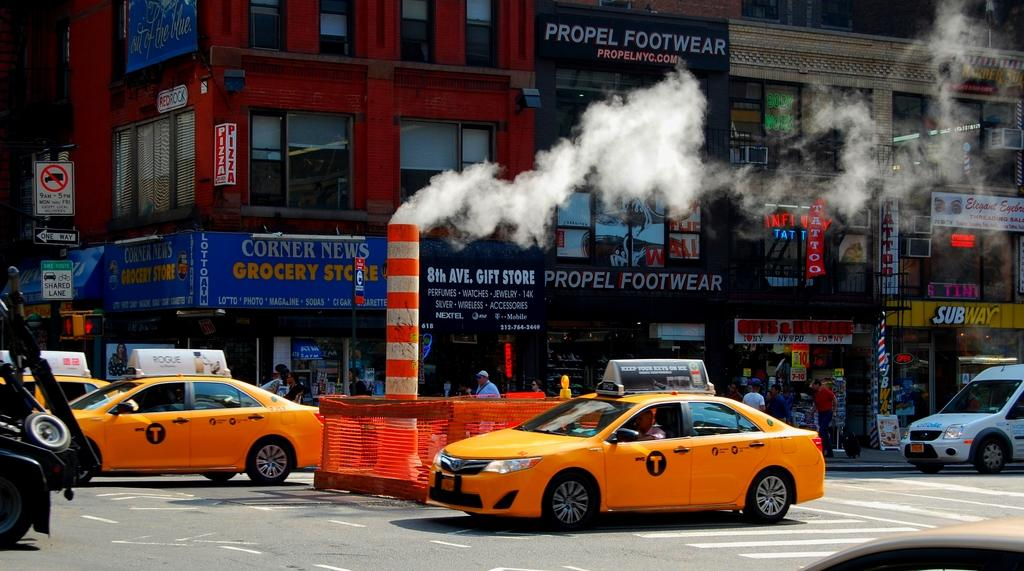<image>
Present a compact description of the photo's key features. One could get money from the ATM and play the Lotto at the store on the corner. 